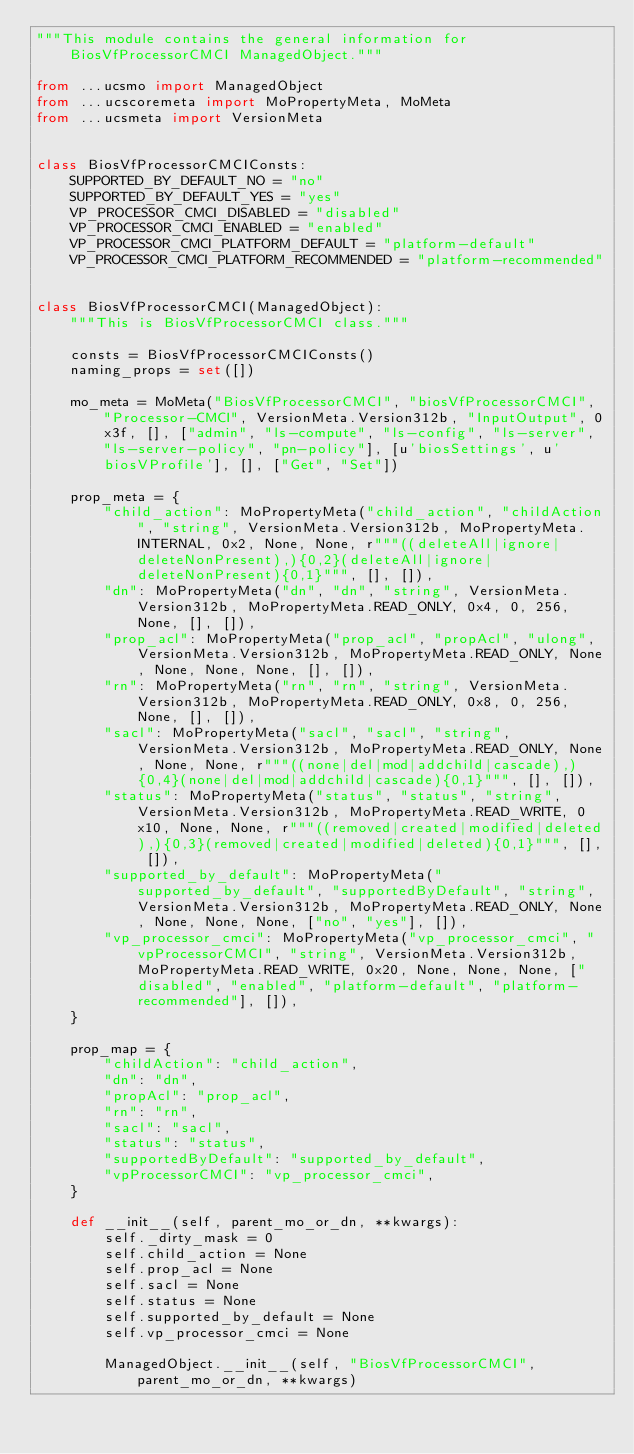<code> <loc_0><loc_0><loc_500><loc_500><_Python_>"""This module contains the general information for BiosVfProcessorCMCI ManagedObject."""

from ...ucsmo import ManagedObject
from ...ucscoremeta import MoPropertyMeta, MoMeta
from ...ucsmeta import VersionMeta


class BiosVfProcessorCMCIConsts:
    SUPPORTED_BY_DEFAULT_NO = "no"
    SUPPORTED_BY_DEFAULT_YES = "yes"
    VP_PROCESSOR_CMCI_DISABLED = "disabled"
    VP_PROCESSOR_CMCI_ENABLED = "enabled"
    VP_PROCESSOR_CMCI_PLATFORM_DEFAULT = "platform-default"
    VP_PROCESSOR_CMCI_PLATFORM_RECOMMENDED = "platform-recommended"


class BiosVfProcessorCMCI(ManagedObject):
    """This is BiosVfProcessorCMCI class."""

    consts = BiosVfProcessorCMCIConsts()
    naming_props = set([])

    mo_meta = MoMeta("BiosVfProcessorCMCI", "biosVfProcessorCMCI", "Processor-CMCI", VersionMeta.Version312b, "InputOutput", 0x3f, [], ["admin", "ls-compute", "ls-config", "ls-server", "ls-server-policy", "pn-policy"], [u'biosSettings', u'biosVProfile'], [], ["Get", "Set"])

    prop_meta = {
        "child_action": MoPropertyMeta("child_action", "childAction", "string", VersionMeta.Version312b, MoPropertyMeta.INTERNAL, 0x2, None, None, r"""((deleteAll|ignore|deleteNonPresent),){0,2}(deleteAll|ignore|deleteNonPresent){0,1}""", [], []), 
        "dn": MoPropertyMeta("dn", "dn", "string", VersionMeta.Version312b, MoPropertyMeta.READ_ONLY, 0x4, 0, 256, None, [], []), 
        "prop_acl": MoPropertyMeta("prop_acl", "propAcl", "ulong", VersionMeta.Version312b, MoPropertyMeta.READ_ONLY, None, None, None, None, [], []), 
        "rn": MoPropertyMeta("rn", "rn", "string", VersionMeta.Version312b, MoPropertyMeta.READ_ONLY, 0x8, 0, 256, None, [], []), 
        "sacl": MoPropertyMeta("sacl", "sacl", "string", VersionMeta.Version312b, MoPropertyMeta.READ_ONLY, None, None, None, r"""((none|del|mod|addchild|cascade),){0,4}(none|del|mod|addchild|cascade){0,1}""", [], []), 
        "status": MoPropertyMeta("status", "status", "string", VersionMeta.Version312b, MoPropertyMeta.READ_WRITE, 0x10, None, None, r"""((removed|created|modified|deleted),){0,3}(removed|created|modified|deleted){0,1}""", [], []), 
        "supported_by_default": MoPropertyMeta("supported_by_default", "supportedByDefault", "string", VersionMeta.Version312b, MoPropertyMeta.READ_ONLY, None, None, None, None, ["no", "yes"], []), 
        "vp_processor_cmci": MoPropertyMeta("vp_processor_cmci", "vpProcessorCMCI", "string", VersionMeta.Version312b, MoPropertyMeta.READ_WRITE, 0x20, None, None, None, ["disabled", "enabled", "platform-default", "platform-recommended"], []), 
    }

    prop_map = {
        "childAction": "child_action", 
        "dn": "dn", 
        "propAcl": "prop_acl", 
        "rn": "rn", 
        "sacl": "sacl", 
        "status": "status", 
        "supportedByDefault": "supported_by_default", 
        "vpProcessorCMCI": "vp_processor_cmci", 
    }

    def __init__(self, parent_mo_or_dn, **kwargs):
        self._dirty_mask = 0
        self.child_action = None
        self.prop_acl = None
        self.sacl = None
        self.status = None
        self.supported_by_default = None
        self.vp_processor_cmci = None

        ManagedObject.__init__(self, "BiosVfProcessorCMCI", parent_mo_or_dn, **kwargs)
</code> 